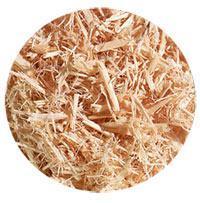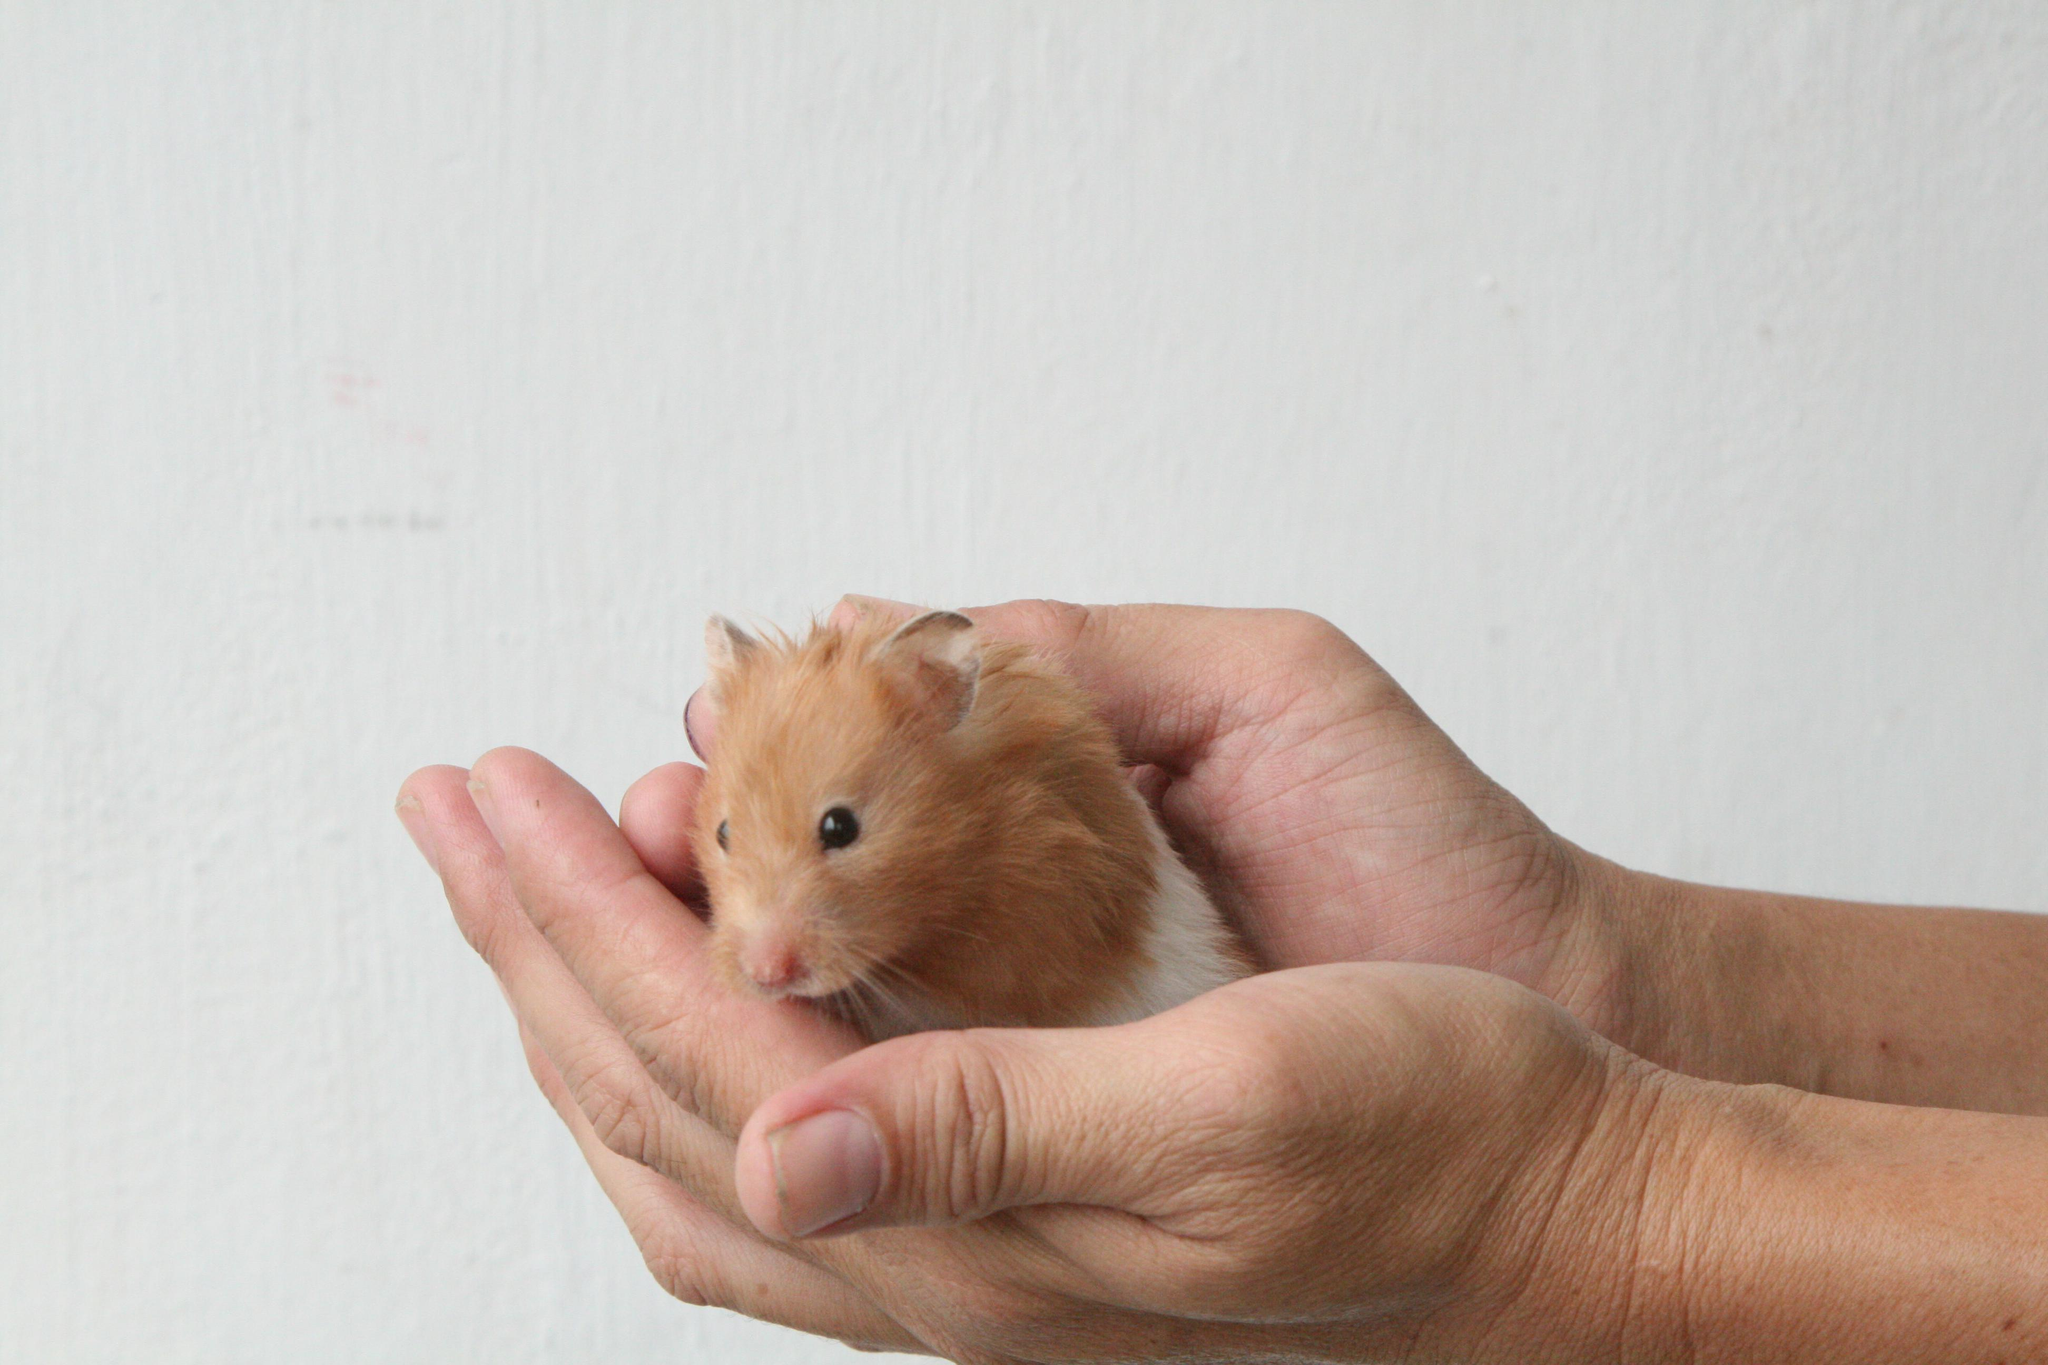The first image is the image on the left, the second image is the image on the right. Analyze the images presented: Is the assertion "There are exactly two hamsters in total." valid? Answer yes or no. No. 